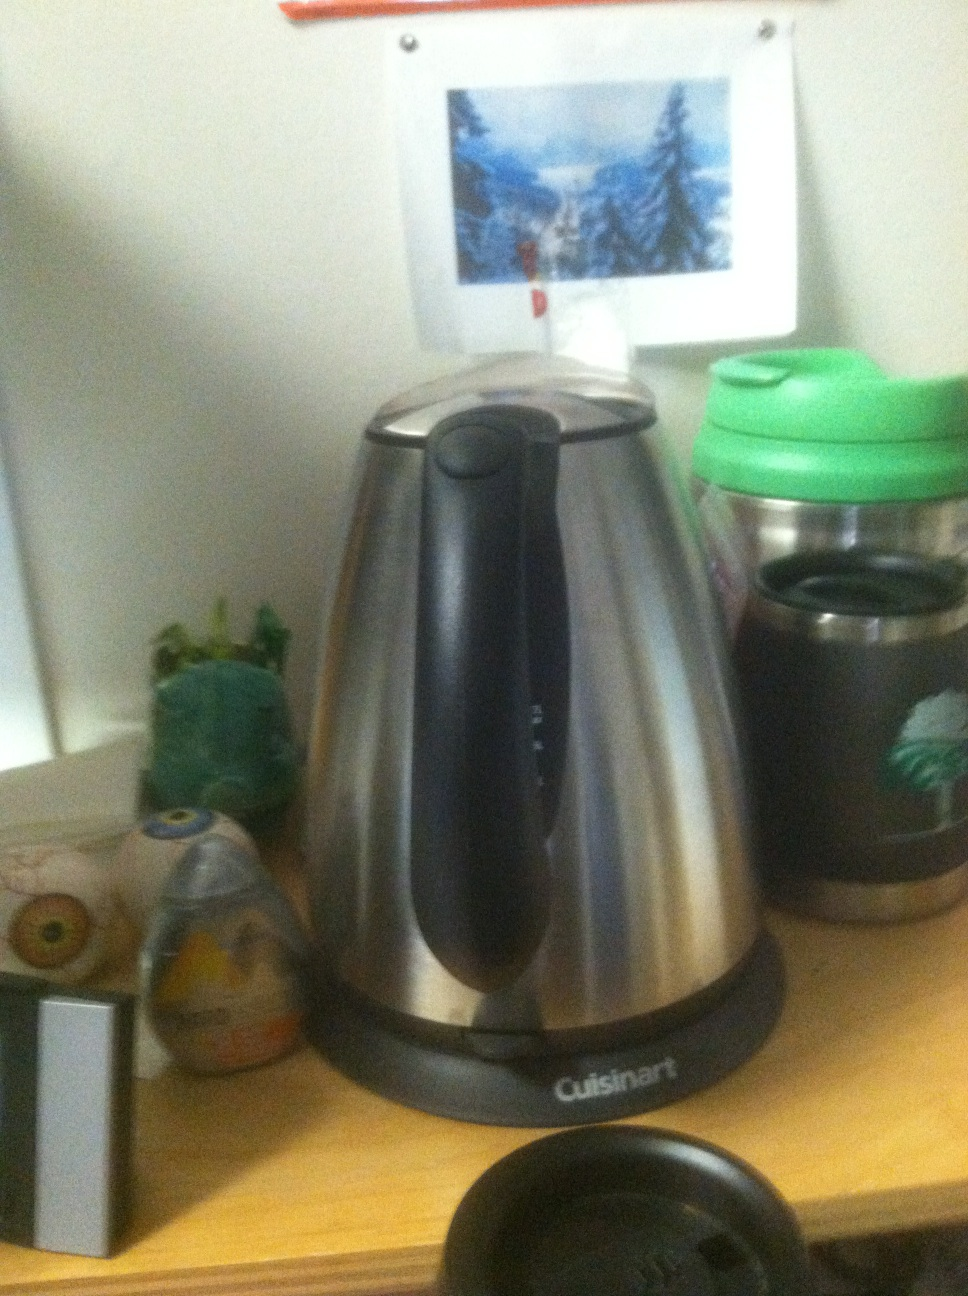What could be the possible reasons for placing it next to other items like a Star Wars cup and a green Starbucks bottle? This arrangement might reflect personalization of space, likely in a casual, personal environment such as a home office or kitchen. Each item, including the coffee pot, contributes to a comfortable and familiar atmosphere for the user. Is there any significance to the way these items are organized? The placement might not follow a specific organizational principle but is more about convenience and personal preference. Items that are used frequently are kept together and easily accessible, which is common in personal workspaces. 